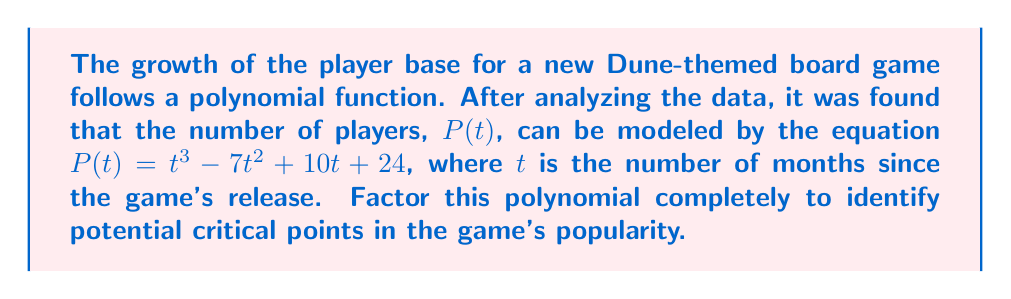Solve this math problem. To factor this polynomial, we'll follow these steps:

1) First, let's check if there are any common factors. In this case, there are none.

2) Next, we'll try to find a rational root. Using the rational root theorem, potential roots are factors of the constant term, 24: ±1, ±2, ±3, ±4, ±6, ±8, ±12, ±24.

3) Testing these values, we find that $P(4) = 0$. So $(t-4)$ is a factor.

4) Divide the polynomial by $(t-4)$:

   $$t^3 - 7t^2 + 10t + 24 = (t-4)(t^2 - 3t - 6)$$

5) Now we need to factor the quadratic $t^2 - 3t - 6$. We can use the quadratic formula or factor by grouping.

6) The quadratic factors as $(t+2)(t-5)$

Therefore, the complete factorization is:

$$P(t) = (t-4)(t+2)(t-5)$$

This factorization reveals that the critical points in the game's popularity occur at 4 months, -2 months (which isn't meaningful in this context), and 5 months after release.
Answer: $P(t) = (t-4)(t+2)(t-5)$ 